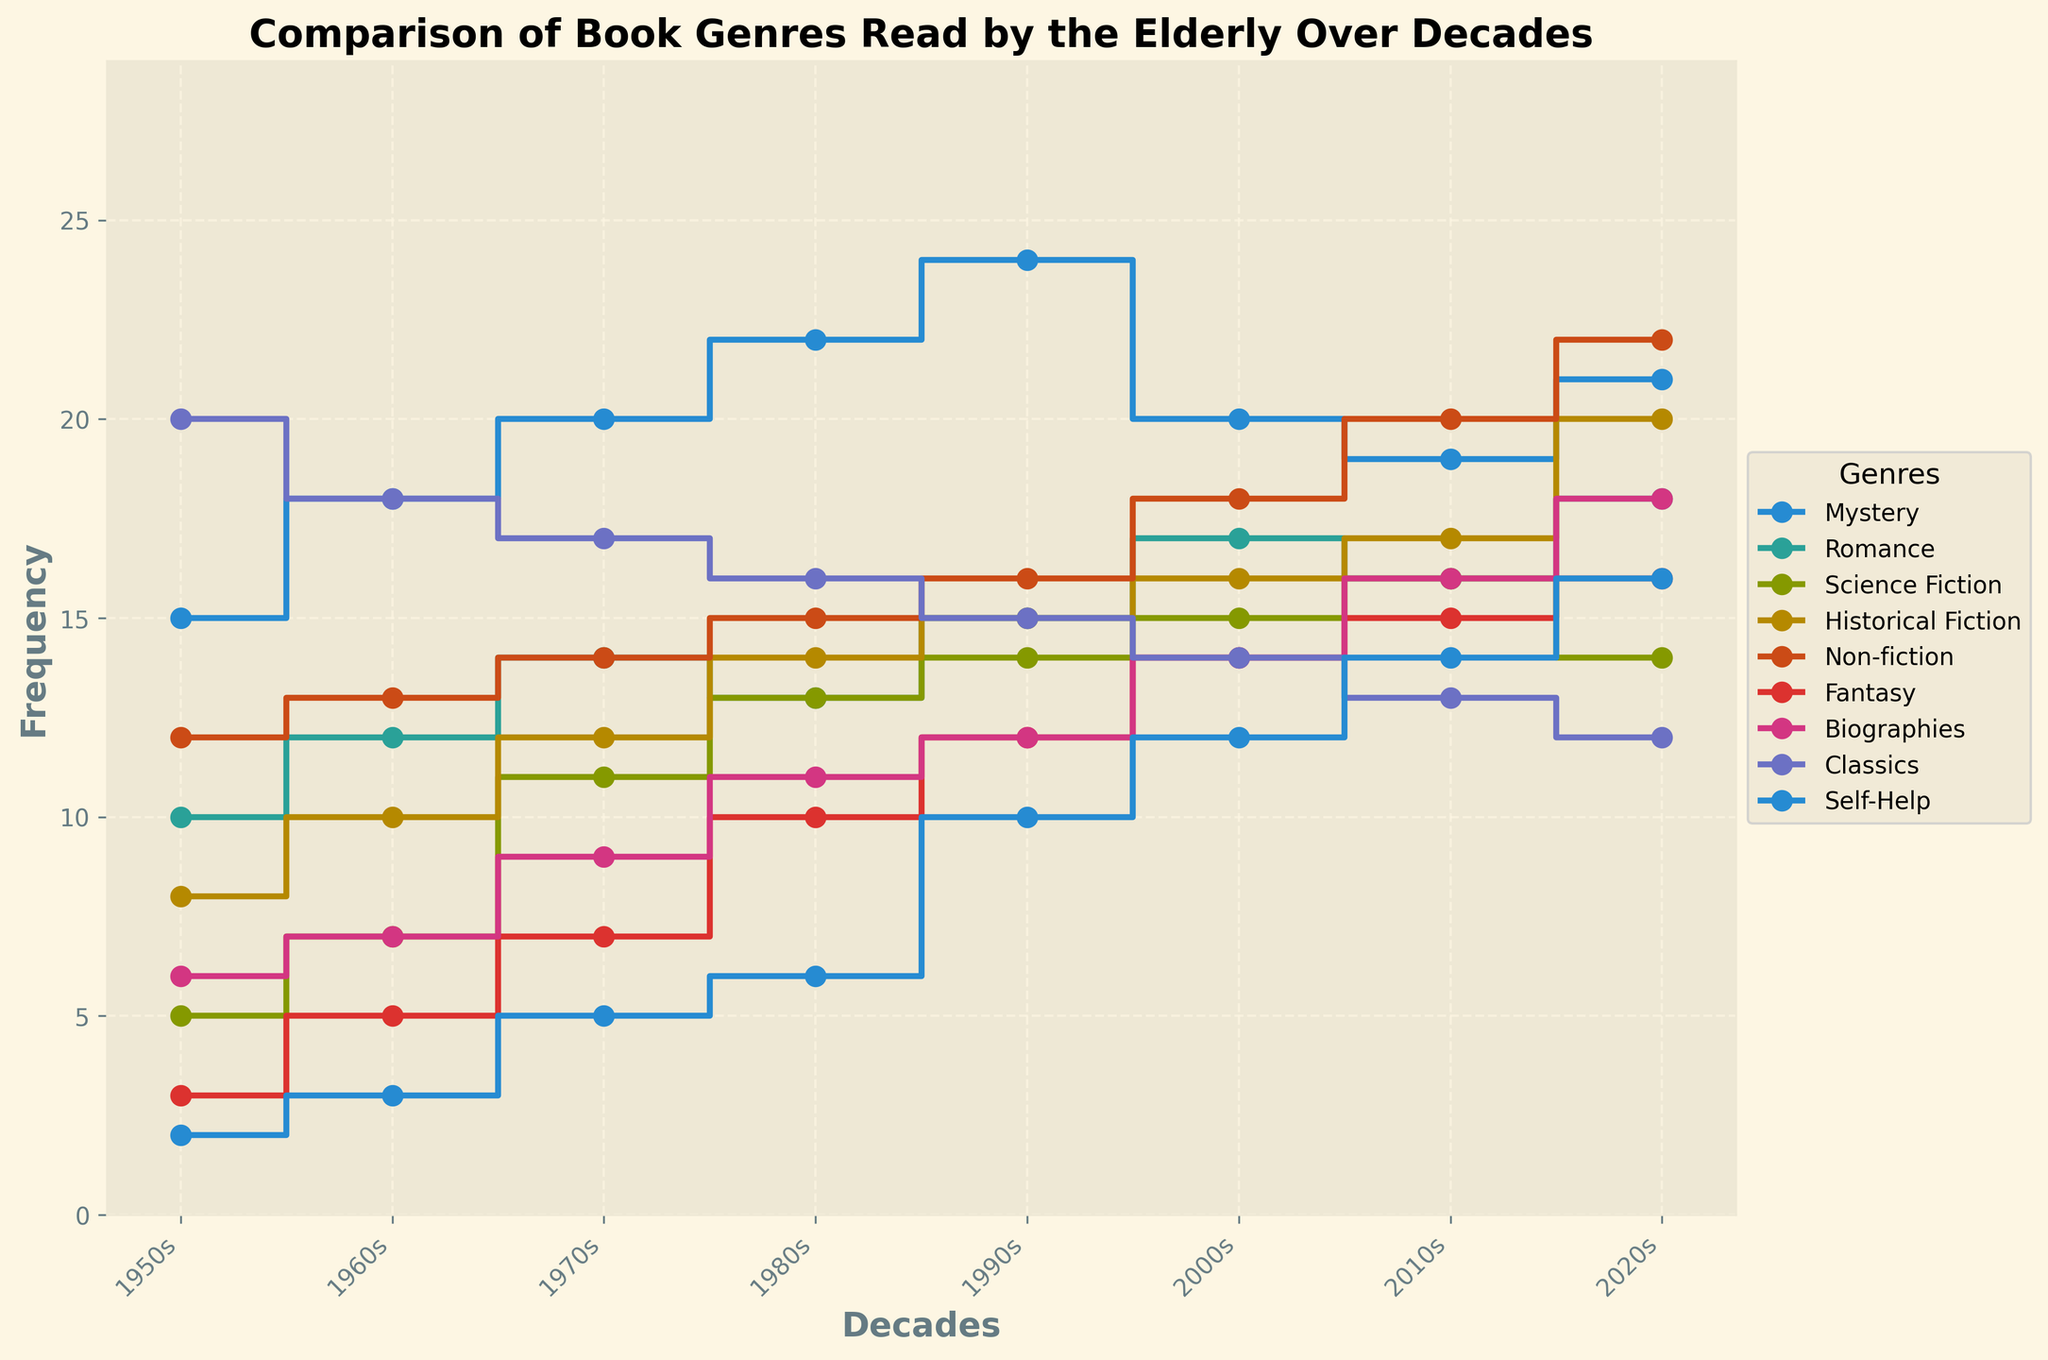What is the title of the plot? The title of the plot is shown at the top of the figure. It reads "Comparison of Book Genres Read by the Elderly Over Decades."
Answer: Comparison of Book Genres Read by the Elderly Over Decades Which genre had the highest frequency in the 1950s? By examining the various points on the stair plot in the 1950s column, we see that "Classics" has the highest frequency with a value of 20.
Answer: Classics How did the frequency of reading "Romance" books change from the 1950s to the 2020s? We can track the "Romance" data points over the decades, starting at 10 in the 1950s and reaching 18 in the 2020s. This shows an overall increase.
Answer: Increased Which genre had the steepest increase in frequency between the 1950s and the 2020s? By comparing the start and end points for each genre, "Fantasy" increased from 3 in the 1950s to 16 in the 2020s, marking a steep increase of 13.
Answer: Fantasy What is the difference in frequency of "Non-fiction" books between the 1980s and 2020s? In the 1980s, "Non-fiction" has a frequency of 15, and in the 2020s, it has a frequency of 22. The difference is 22 - 15.
Answer: 7 Does any genre show a consistent decline over the decades? "Classics" shows a consistent decline as it starts at 20 in the 1950s and gradually decreases to 12 by the 2020s.
Answer: Yes, Classics Which genre had the smallest change in frequency from the 1950s to the 2020s? By comparing the changes for each genre, "Mystery" had a rise from 15 to 21, showing an increase of 6, which is relatively small compared to others.
Answer: Mystery What was the frequency of "Self-Help" books in the 2010s? The plot shows a data point for "Self-Help" at 14 in the 2010s column.
Answer: 14 Compare the frequency of "Science Fiction" and "Historical Fiction" in the 1970s. Which genre was read more commonly? In the 1970s, "Science Fiction" has a frequency of 11 and "Historical Fiction" has a frequency of 12. So, "Historical Fiction" was read more commonly.
Answer: Historical Fiction How many genres had a frequency above 10 in the 1990s? By counting the genres in the 1990s column that have frequencies above 10: Mystery (24), Romance (15), Science Fiction (14), Historical Fiction (15), Non-fiction (16), Fantasy (12), Biographies (12), Self-Help (10). There are 7 such genres.
Answer: 7 